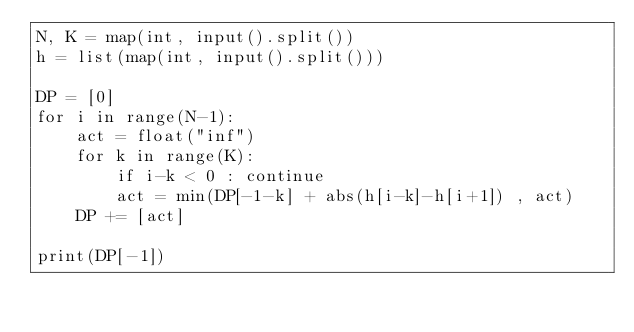Convert code to text. <code><loc_0><loc_0><loc_500><loc_500><_Python_>N, K = map(int, input().split())
h = list(map(int, input().split()))
 
DP = [0]
for i in range(N-1):
    act = float("inf")
    for k in range(K):
        if i-k < 0 : continue
        act = min(DP[-1-k] + abs(h[i-k]-h[i+1]) , act)
    DP += [act]
 
print(DP[-1])</code> 